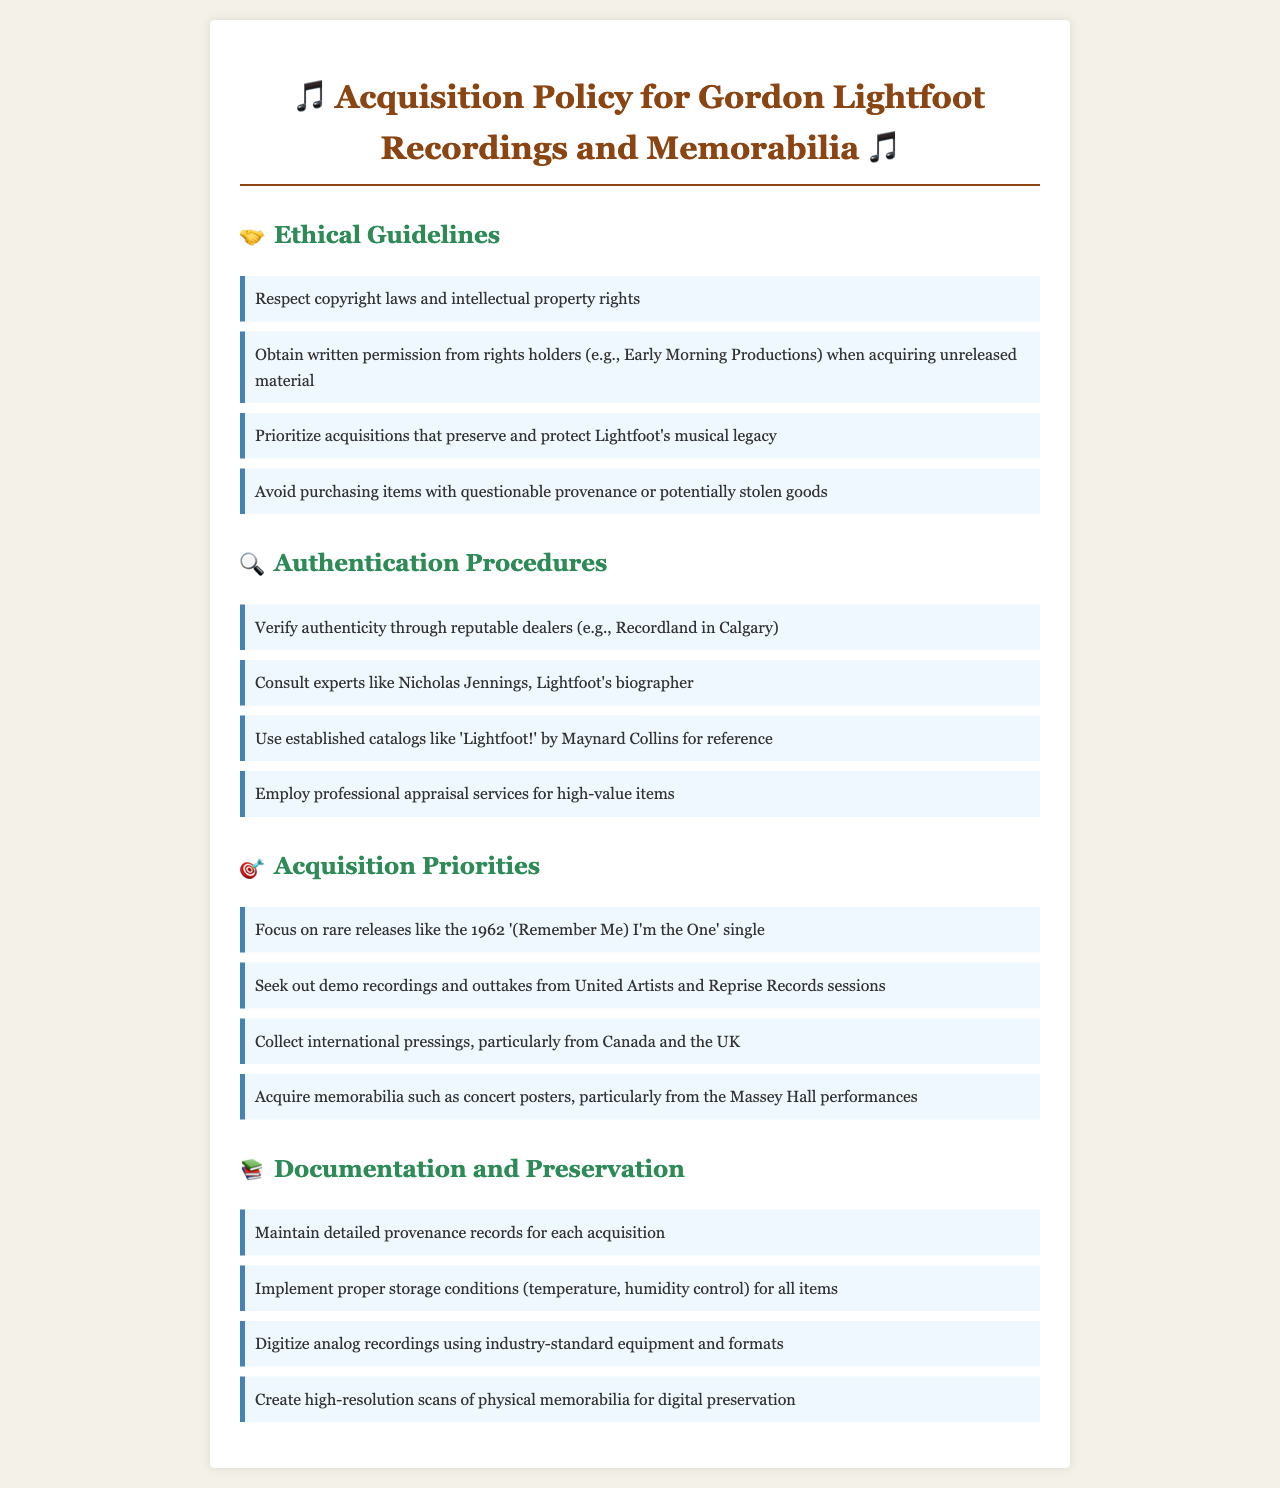What is the document about? The document outlines the acquisition policy for obtaining recordings and memorabilia related to Gordon Lightfoot.
Answer: Acquisition Policy for Gordon Lightfoot Recordings and Memorabilia Who should you obtain permission from when acquiring unreleased material? The document specifies that written permission should be obtained from rights holders such as Early Morning Productions.
Answer: Early Morning Productions What type of memorabilia is prioritized for acquisition specifically? The document states that concert posters from the Massey Hall performances are particularly prioritized.
Answer: Concert posters from Massey Hall performances What is one way to verify authenticity of an item? The policy suggests verifying authenticity through reputable dealers.
Answer: Reputable dealers Who is mentioned as an expert to consult for authentication of items? The document mentions Nicholas Jennings as an expert to consult.
Answer: Nicholas Jennings Which release type is highlighted as a focus for acquisitions? The document highlights rare releases like the 1962 '(Remember Me) I'm the One' single.
Answer: 1962 '(Remember Me) I'm the One' single What should be maintained for each acquisition? The document indicates that detailed provenance records should be maintained for each acquisition.
Answer: Detailed provenance records What should be done with analog recordings for preservation? The document states that analog recordings should be digitized using industry-standard equipment and formats.
Answer: Digitize analog recordings 